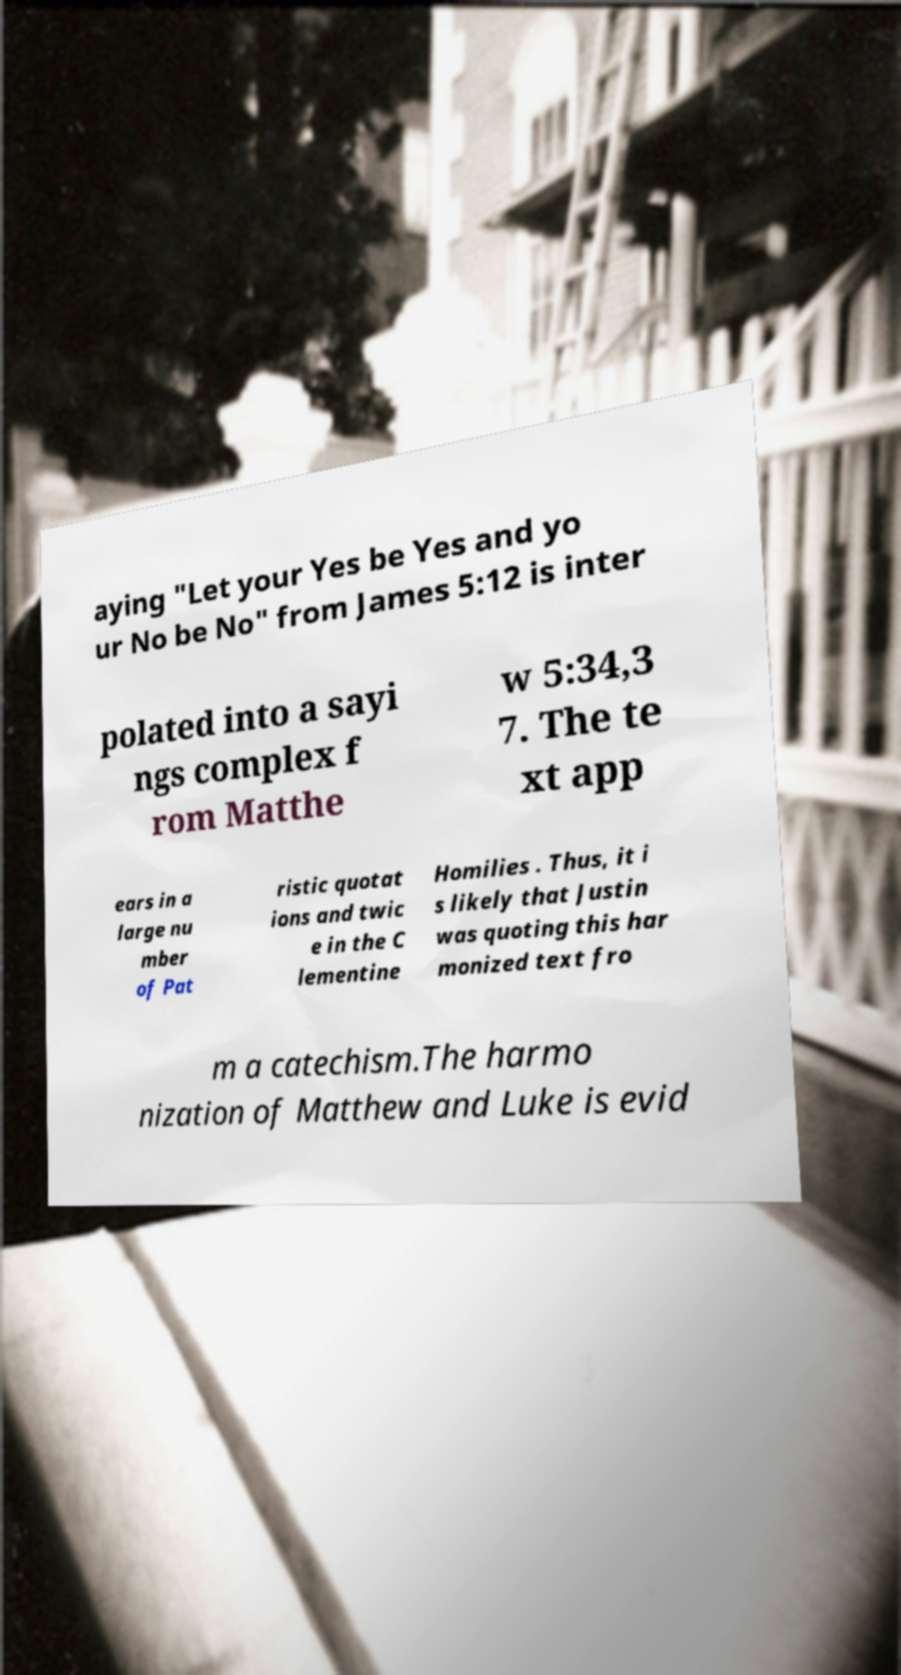Can you accurately transcribe the text from the provided image for me? aying "Let your Yes be Yes and yo ur No be No" from James 5:12 is inter polated into a sayi ngs complex f rom Matthe w 5:34,3 7. The te xt app ears in a large nu mber of Pat ristic quotat ions and twic e in the C lementine Homilies . Thus, it i s likely that Justin was quoting this har monized text fro m a catechism.The harmo nization of Matthew and Luke is evid 